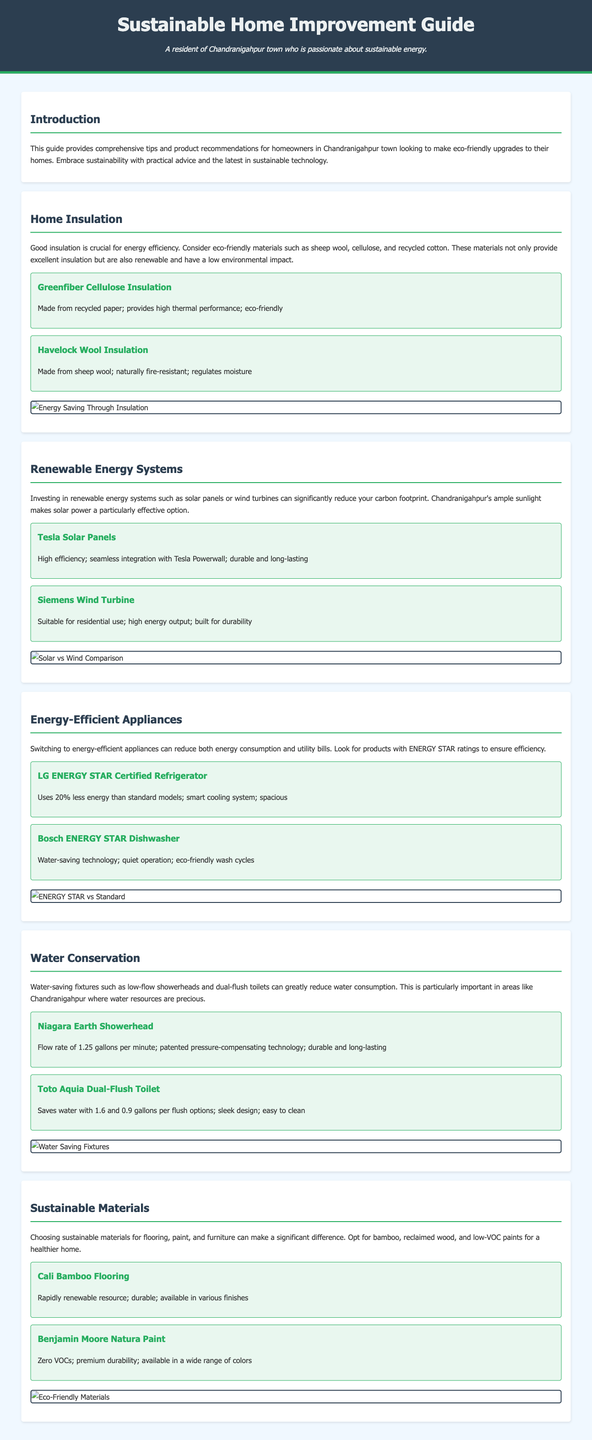What is the title of the guide? The title is presented in the header of the document as the main headline.
Answer: Sustainable Home Improvement Guide What eco-friendly insulation material is made from recycled paper? The document lists specific products under home insulation, identifying their materials.
Answer: Greenfiber Cellulose Insulation Which product is recommended for water conservation with a flow rate of 1.25 gallons per minute? The document provides details about water-saving fixtures, mentioning the flow rates for specific products.
Answer: Niagara Earth Showerhead What is the primary focus of the Renewable Energy Systems section? The document outlines the benefits of investing in renewable energy, particularly relevant to local conditions.
Answer: Solar power How many gallons does the Toto Aquia Dual-Flush Toilet save with its flush options? The recommendation lists the water-saving capabilities of the product, specifying its flush options.
Answer: 1.6 and 0.9 gallons Which type of paint is recommended for its zero VOCs? The sustainable materials section highlights paint options that prioritize health and environmental standards.
Answer: Benjamin Moore Natura Paint What is the purpose of the infographic in the Energy-Efficient Appliances section? The infographics are provided to visually compare energy ratings and features of appliances.
Answer: Comparison What feature makes Havelock Wool Insulation unique? The document includes specific characteristics for each insulation type, explaining their benefits.
Answer: Naturally fire-resistant 